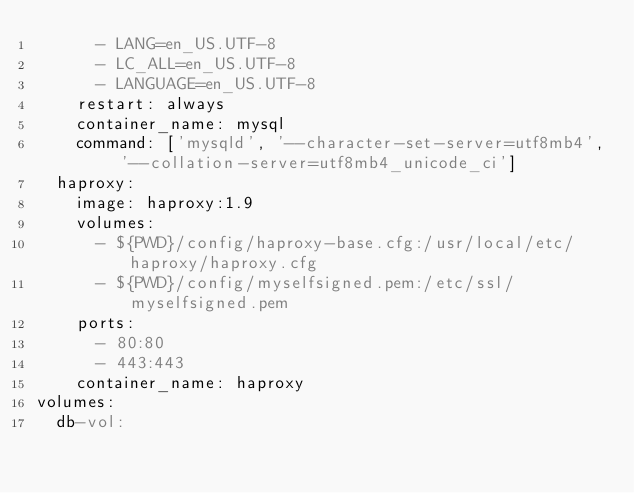<code> <loc_0><loc_0><loc_500><loc_500><_YAML_>      - LANG=en_US.UTF-8
      - LC_ALL=en_US.UTF-8
      - LANGUAGE=en_US.UTF-8
    restart: always
    container_name: mysql
    command: ['mysqld', '--character-set-server=utf8mb4', '--collation-server=utf8mb4_unicode_ci']
  haproxy:
    image: haproxy:1.9
    volumes:
      - ${PWD}/config/haproxy-base.cfg:/usr/local/etc/haproxy/haproxy.cfg
      - ${PWD}/config/myselfsigned.pem:/etc/ssl/myselfsigned.pem
    ports:
      - 80:80
      - 443:443
    container_name: haproxy
volumes:
  db-vol:</code> 